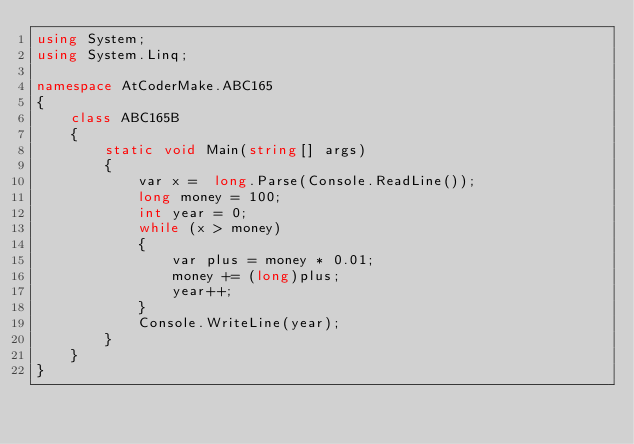Convert code to text. <code><loc_0><loc_0><loc_500><loc_500><_C#_>using System;
using System.Linq;

namespace AtCoderMake.ABC165
{
    class ABC165B
    {
        static void Main(string[] args)
        {
            var x =  long.Parse(Console.ReadLine());
            long money = 100;
            int year = 0;
            while (x > money)
            {
                var plus = money * 0.01;
                money += (long)plus;
                year++;
            }
            Console.WriteLine(year);
        }
    }
}</code> 